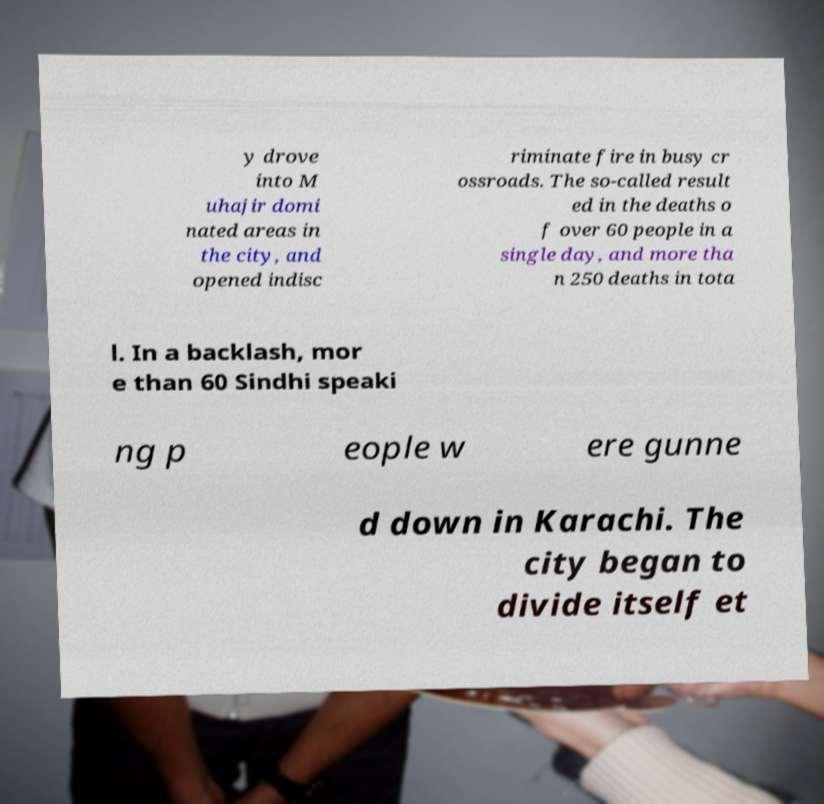Please read and relay the text visible in this image. What does it say? y drove into M uhajir domi nated areas in the city, and opened indisc riminate fire in busy cr ossroads. The so-called result ed in the deaths o f over 60 people in a single day, and more tha n 250 deaths in tota l. In a backlash, mor e than 60 Sindhi speaki ng p eople w ere gunne d down in Karachi. The city began to divide itself et 